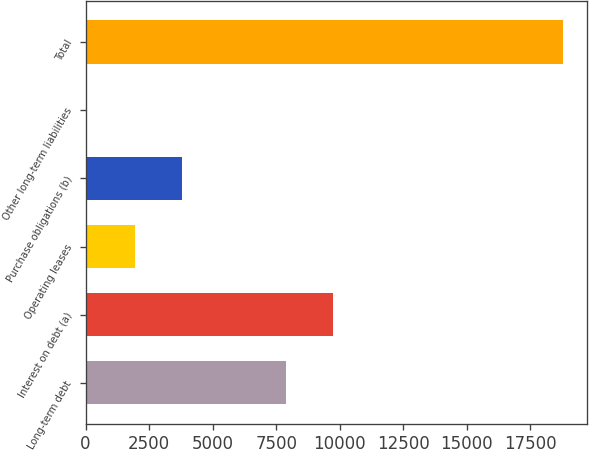Convert chart to OTSL. <chart><loc_0><loc_0><loc_500><loc_500><bar_chart><fcel>Long-term debt<fcel>Interest on debt (a)<fcel>Operating leases<fcel>Purchase obligations (b)<fcel>Other long-term liabilities<fcel>Total<nl><fcel>7871<fcel>9746<fcel>1929<fcel>3804<fcel>54<fcel>18804<nl></chart> 